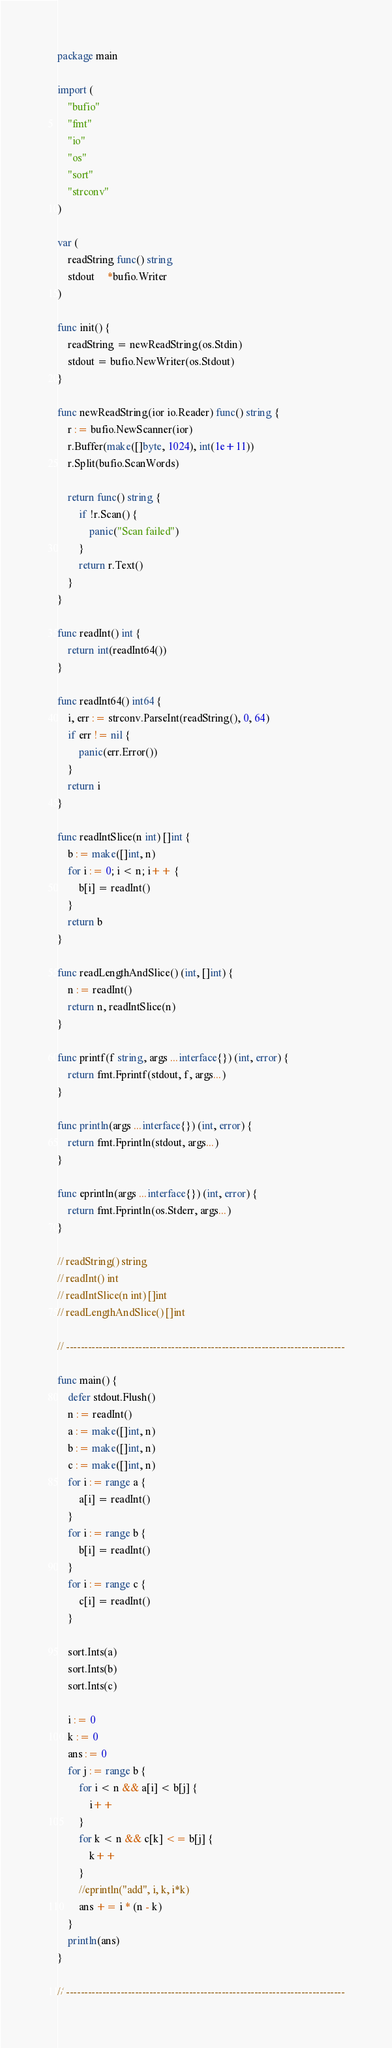<code> <loc_0><loc_0><loc_500><loc_500><_Go_>package main

import (
	"bufio"
	"fmt"
	"io"
	"os"
	"sort"
	"strconv"
)

var (
	readString func() string
	stdout     *bufio.Writer
)

func init() {
	readString = newReadString(os.Stdin)
	stdout = bufio.NewWriter(os.Stdout)
}

func newReadString(ior io.Reader) func() string {
	r := bufio.NewScanner(ior)
	r.Buffer(make([]byte, 1024), int(1e+11))
	r.Split(bufio.ScanWords)

	return func() string {
		if !r.Scan() {
			panic("Scan failed")
		}
		return r.Text()
	}
}

func readInt() int {
	return int(readInt64())
}

func readInt64() int64 {
	i, err := strconv.ParseInt(readString(), 0, 64)
	if err != nil {
		panic(err.Error())
	}
	return i
}

func readIntSlice(n int) []int {
	b := make([]int, n)
	for i := 0; i < n; i++ {
		b[i] = readInt()
	}
	return b
}

func readLengthAndSlice() (int, []int) {
	n := readInt()
	return n, readIntSlice(n)
}

func printf(f string, args ...interface{}) (int, error) {
	return fmt.Fprintf(stdout, f, args...)
}

func println(args ...interface{}) (int, error) {
	return fmt.Fprintln(stdout, args...)
}

func eprintln(args ...interface{}) (int, error) {
	return fmt.Fprintln(os.Stderr, args...)
}

// readString() string
// readInt() int
// readIntSlice(n int) []int
// readLengthAndSlice() []int

// -----------------------------------------------------------------------------

func main() {
	defer stdout.Flush()
	n := readInt()
	a := make([]int, n)
	b := make([]int, n)
	c := make([]int, n)
	for i := range a {
		a[i] = readInt()
	}
	for i := range b {
		b[i] = readInt()
	}
	for i := range c {
		c[i] = readInt()
	}

	sort.Ints(a)
	sort.Ints(b)
	sort.Ints(c)

	i := 0
	k := 0
	ans := 0
	for j := range b {
		for i < n && a[i] < b[j] {
			i++
		}
		for k < n && c[k] <= b[j] {
			k++
		}
		//eprintln("add", i, k, i*k)
		ans += i * (n - k)
	}
	println(ans)
}

// -----------------------------------------------------------------------------
</code> 